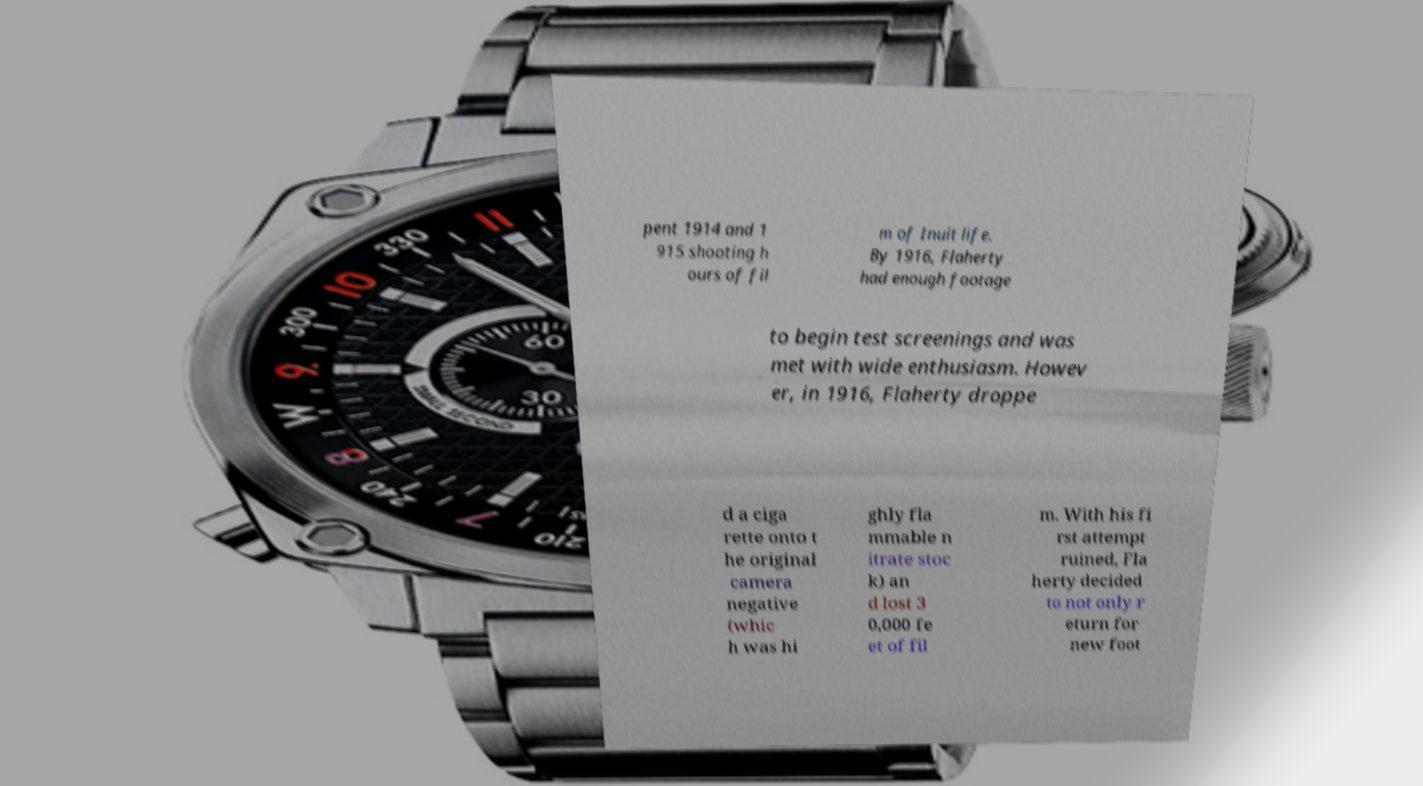For documentation purposes, I need the text within this image transcribed. Could you provide that? pent 1914 and 1 915 shooting h ours of fil m of Inuit life. By 1916, Flaherty had enough footage to begin test screenings and was met with wide enthusiasm. Howev er, in 1916, Flaherty droppe d a ciga rette onto t he original camera negative (whic h was hi ghly fla mmable n itrate stoc k) an d lost 3 0,000 fe et of fil m. With his fi rst attempt ruined, Fla herty decided to not only r eturn for new foot 